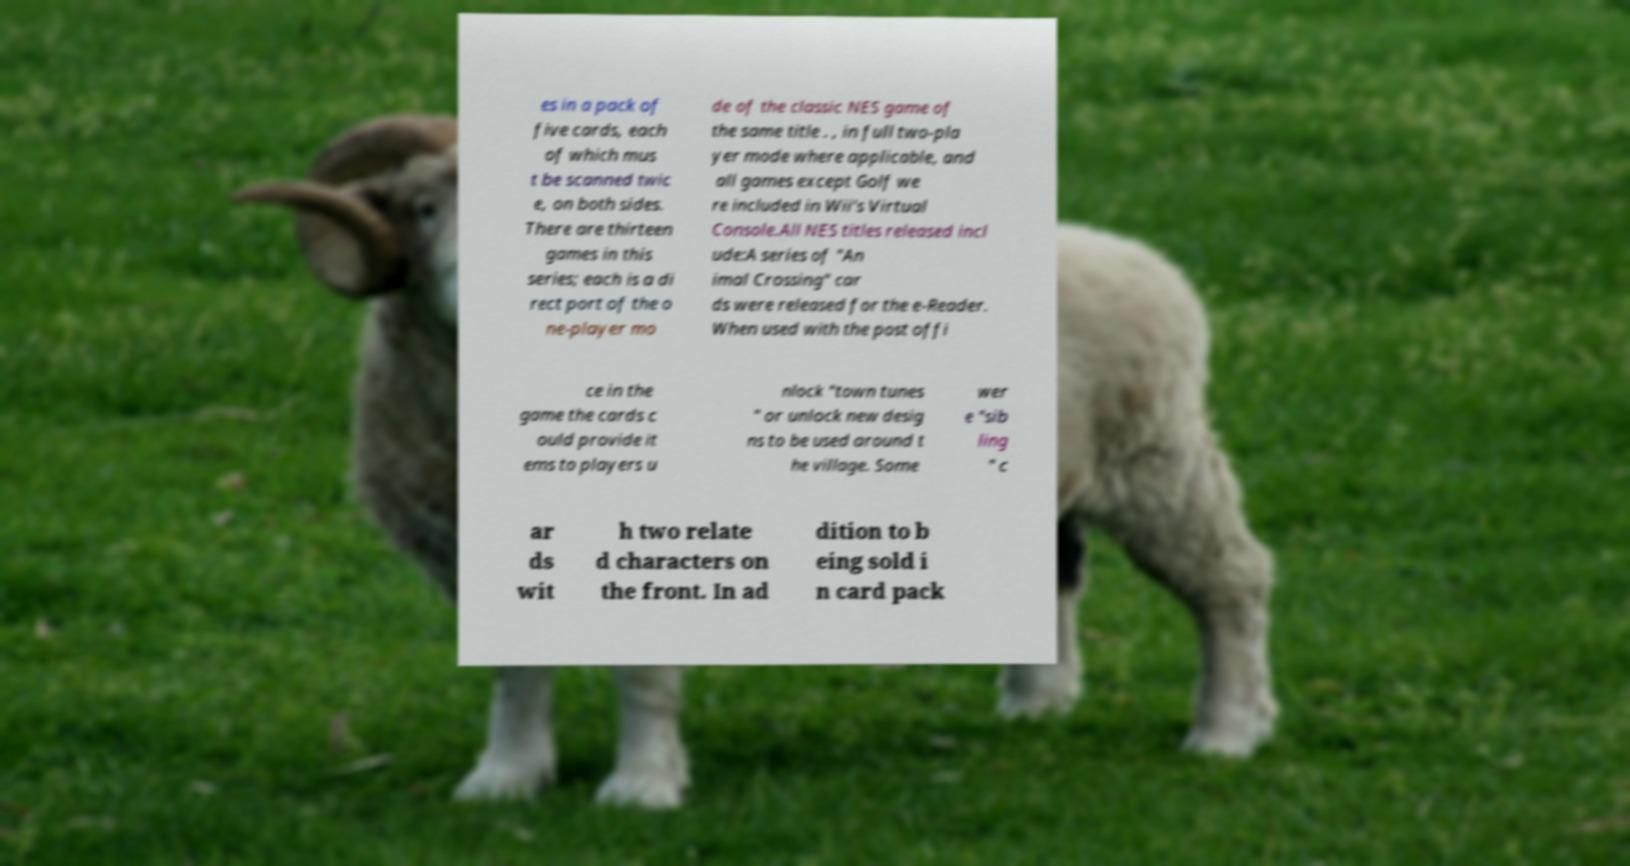Can you read and provide the text displayed in the image?This photo seems to have some interesting text. Can you extract and type it out for me? es in a pack of five cards, each of which mus t be scanned twic e, on both sides. There are thirteen games in this series; each is a di rect port of the o ne-player mo de of the classic NES game of the same title . , in full two-pla yer mode where applicable, and all games except Golf we re included in Wii's Virtual Console.All NES titles released incl ude:A series of "An imal Crossing" car ds were released for the e-Reader. When used with the post offi ce in the game the cards c ould provide it ems to players u nlock "town tunes " or unlock new desig ns to be used around t he village. Some wer e "sib ling " c ar ds wit h two relate d characters on the front. In ad dition to b eing sold i n card pack 